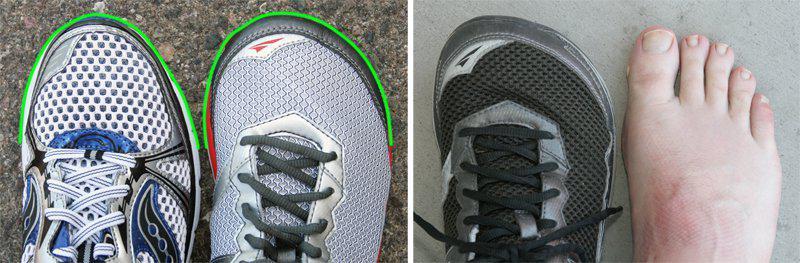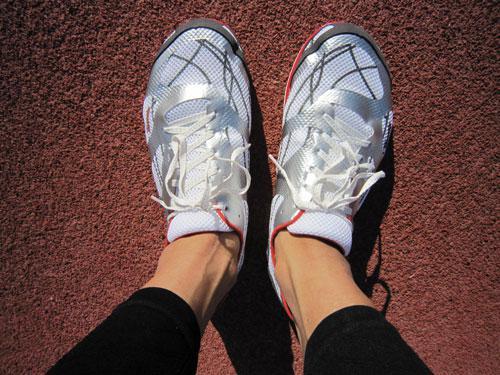The first image is the image on the left, the second image is the image on the right. Examine the images to the left and right. Is the description "At least one image shows a pair of running shoes that are being worn on a person's feet" accurate? Answer yes or no. Yes. The first image is the image on the left, the second image is the image on the right. Given the left and right images, does the statement "One image is a top-view of human feet wearing matching sneakers with white laces." hold true? Answer yes or no. Yes. 